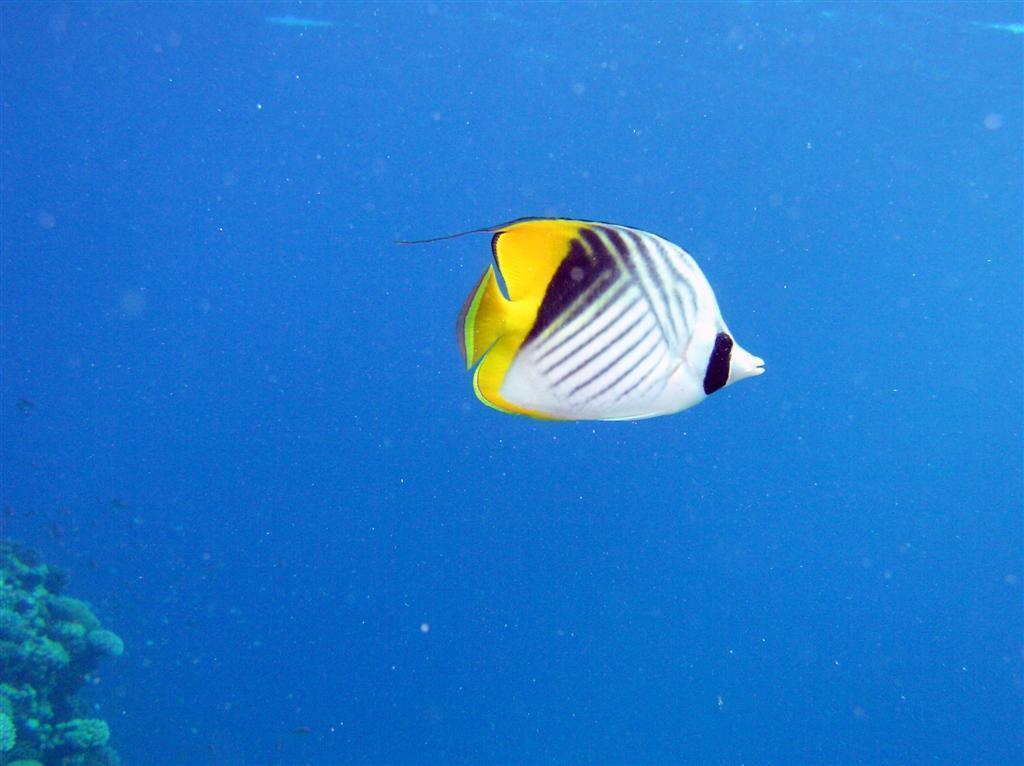Describe this image in one or two sentences. In this image we can see a fish in the water, also we can see a plant. 